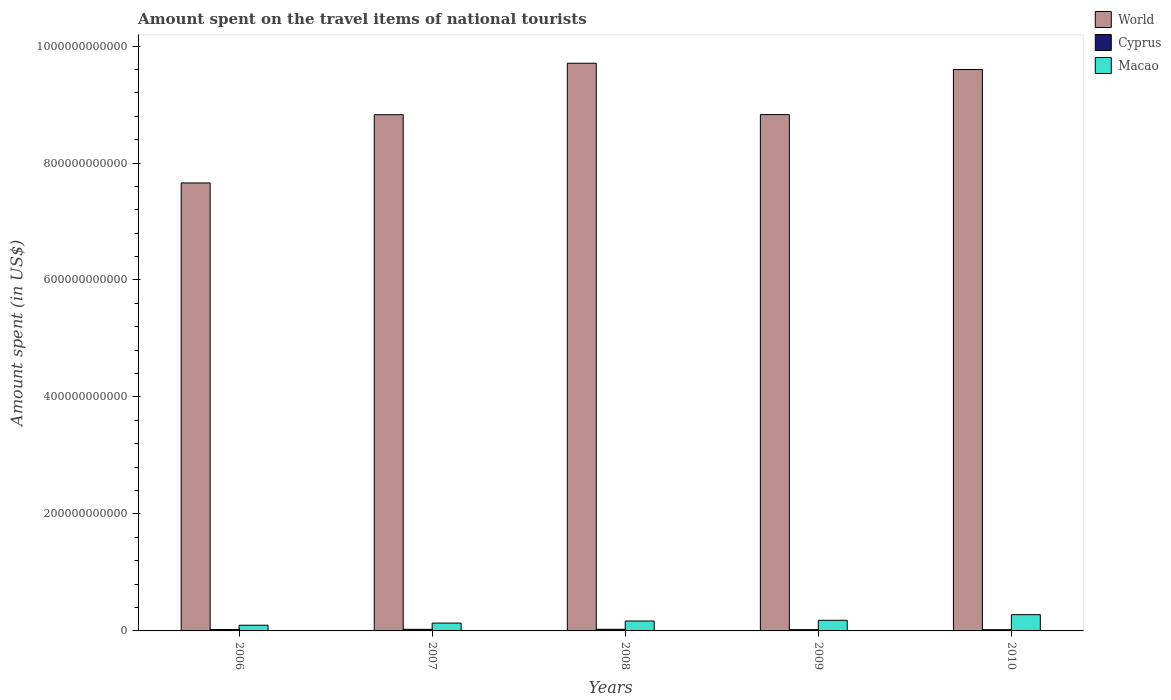How many groups of bars are there?
Make the answer very short. 5. Are the number of bars per tick equal to the number of legend labels?
Give a very brief answer. Yes. Are the number of bars on each tick of the X-axis equal?
Offer a terse response. Yes. How many bars are there on the 3rd tick from the left?
Provide a succinct answer. 3. How many bars are there on the 2nd tick from the right?
Make the answer very short. 3. What is the amount spent on the travel items of national tourists in Cyprus in 2006?
Ensure brevity in your answer.  2.38e+09. Across all years, what is the maximum amount spent on the travel items of national tourists in World?
Ensure brevity in your answer.  9.71e+11. Across all years, what is the minimum amount spent on the travel items of national tourists in Cyprus?
Give a very brief answer. 2.11e+09. What is the total amount spent on the travel items of national tourists in Macao in the graph?
Offer a very short reply. 8.60e+1. What is the difference between the amount spent on the travel items of national tourists in Cyprus in 2007 and that in 2010?
Offer a very short reply. 5.78e+08. What is the difference between the amount spent on the travel items of national tourists in Cyprus in 2008 and the amount spent on the travel items of national tourists in World in 2010?
Provide a short and direct response. -9.57e+11. What is the average amount spent on the travel items of national tourists in World per year?
Provide a succinct answer. 8.92e+11. In the year 2006, what is the difference between the amount spent on the travel items of national tourists in World and amount spent on the travel items of national tourists in Macao?
Make the answer very short. 7.56e+11. In how many years, is the amount spent on the travel items of national tourists in World greater than 360000000000 US$?
Offer a very short reply. 5. What is the ratio of the amount spent on the travel items of national tourists in World in 2006 to that in 2007?
Provide a short and direct response. 0.87. What is the difference between the highest and the second highest amount spent on the travel items of national tourists in World?
Provide a short and direct response. 1.07e+1. What is the difference between the highest and the lowest amount spent on the travel items of national tourists in World?
Offer a very short reply. 2.05e+11. Is the sum of the amount spent on the travel items of national tourists in World in 2007 and 2009 greater than the maximum amount spent on the travel items of national tourists in Macao across all years?
Your answer should be very brief. Yes. What does the 1st bar from the right in 2009 represents?
Offer a terse response. Macao. What is the difference between two consecutive major ticks on the Y-axis?
Offer a very short reply. 2.00e+11. Does the graph contain grids?
Keep it short and to the point. No. Where does the legend appear in the graph?
Your answer should be compact. Top right. How are the legend labels stacked?
Your response must be concise. Vertical. What is the title of the graph?
Your answer should be very brief. Amount spent on the travel items of national tourists. What is the label or title of the Y-axis?
Make the answer very short. Amount spent (in US$). What is the Amount spent (in US$) of World in 2006?
Ensure brevity in your answer.  7.66e+11. What is the Amount spent (in US$) of Cyprus in 2006?
Your response must be concise. 2.38e+09. What is the Amount spent (in US$) in Macao in 2006?
Keep it short and to the point. 9.75e+09. What is the Amount spent (in US$) of World in 2007?
Give a very brief answer. 8.83e+11. What is the Amount spent (in US$) in Cyprus in 2007?
Provide a succinct answer. 2.69e+09. What is the Amount spent (in US$) of Macao in 2007?
Ensure brevity in your answer.  1.34e+1. What is the Amount spent (in US$) of World in 2008?
Ensure brevity in your answer.  9.71e+11. What is the Amount spent (in US$) in Cyprus in 2008?
Provide a succinct answer. 2.78e+09. What is the Amount spent (in US$) of Macao in 2008?
Give a very brief answer. 1.69e+1. What is the Amount spent (in US$) of World in 2009?
Your answer should be compact. 8.83e+11. What is the Amount spent (in US$) of Cyprus in 2009?
Give a very brief answer. 2.20e+09. What is the Amount spent (in US$) of Macao in 2009?
Offer a terse response. 1.81e+1. What is the Amount spent (in US$) of World in 2010?
Your answer should be compact. 9.60e+11. What is the Amount spent (in US$) of Cyprus in 2010?
Provide a succinct answer. 2.11e+09. What is the Amount spent (in US$) in Macao in 2010?
Ensure brevity in your answer.  2.78e+1. Across all years, what is the maximum Amount spent (in US$) of World?
Keep it short and to the point. 9.71e+11. Across all years, what is the maximum Amount spent (in US$) in Cyprus?
Provide a short and direct response. 2.78e+09. Across all years, what is the maximum Amount spent (in US$) of Macao?
Your response must be concise. 2.78e+1. Across all years, what is the minimum Amount spent (in US$) in World?
Your response must be concise. 7.66e+11. Across all years, what is the minimum Amount spent (in US$) of Cyprus?
Offer a very short reply. 2.11e+09. Across all years, what is the minimum Amount spent (in US$) of Macao?
Offer a very short reply. 9.75e+09. What is the total Amount spent (in US$) of World in the graph?
Ensure brevity in your answer.  4.46e+12. What is the total Amount spent (in US$) of Cyprus in the graph?
Your response must be concise. 1.21e+1. What is the total Amount spent (in US$) of Macao in the graph?
Provide a short and direct response. 8.60e+1. What is the difference between the Amount spent (in US$) of World in 2006 and that in 2007?
Provide a short and direct response. -1.17e+11. What is the difference between the Amount spent (in US$) in Cyprus in 2006 and that in 2007?
Ensure brevity in your answer.  -3.05e+08. What is the difference between the Amount spent (in US$) of Macao in 2006 and that in 2007?
Offer a terse response. -3.66e+09. What is the difference between the Amount spent (in US$) of World in 2006 and that in 2008?
Your answer should be compact. -2.05e+11. What is the difference between the Amount spent (in US$) of Cyprus in 2006 and that in 2008?
Offer a terse response. -3.98e+08. What is the difference between the Amount spent (in US$) of Macao in 2006 and that in 2008?
Your answer should be compact. -7.20e+09. What is the difference between the Amount spent (in US$) in World in 2006 and that in 2009?
Ensure brevity in your answer.  -1.17e+11. What is the difference between the Amount spent (in US$) of Cyprus in 2006 and that in 2009?
Ensure brevity in your answer.  1.86e+08. What is the difference between the Amount spent (in US$) of Macao in 2006 and that in 2009?
Provide a succinct answer. -8.39e+09. What is the difference between the Amount spent (in US$) of World in 2006 and that in 2010?
Your response must be concise. -1.94e+11. What is the difference between the Amount spent (in US$) in Cyprus in 2006 and that in 2010?
Provide a short and direct response. 2.73e+08. What is the difference between the Amount spent (in US$) of Macao in 2006 and that in 2010?
Ensure brevity in your answer.  -1.81e+1. What is the difference between the Amount spent (in US$) in World in 2007 and that in 2008?
Your response must be concise. -8.79e+1. What is the difference between the Amount spent (in US$) of Cyprus in 2007 and that in 2008?
Ensure brevity in your answer.  -9.30e+07. What is the difference between the Amount spent (in US$) of Macao in 2007 and that in 2008?
Ensure brevity in your answer.  -3.54e+09. What is the difference between the Amount spent (in US$) of World in 2007 and that in 2009?
Ensure brevity in your answer.  -1.73e+08. What is the difference between the Amount spent (in US$) of Cyprus in 2007 and that in 2009?
Offer a very short reply. 4.91e+08. What is the difference between the Amount spent (in US$) of Macao in 2007 and that in 2009?
Offer a very short reply. -4.74e+09. What is the difference between the Amount spent (in US$) in World in 2007 and that in 2010?
Offer a very short reply. -7.72e+1. What is the difference between the Amount spent (in US$) in Cyprus in 2007 and that in 2010?
Make the answer very short. 5.78e+08. What is the difference between the Amount spent (in US$) of Macao in 2007 and that in 2010?
Keep it short and to the point. -1.44e+1. What is the difference between the Amount spent (in US$) of World in 2008 and that in 2009?
Ensure brevity in your answer.  8.78e+1. What is the difference between the Amount spent (in US$) in Cyprus in 2008 and that in 2009?
Provide a succinct answer. 5.84e+08. What is the difference between the Amount spent (in US$) in Macao in 2008 and that in 2009?
Make the answer very short. -1.19e+09. What is the difference between the Amount spent (in US$) in World in 2008 and that in 2010?
Ensure brevity in your answer.  1.07e+1. What is the difference between the Amount spent (in US$) of Cyprus in 2008 and that in 2010?
Your answer should be compact. 6.71e+08. What is the difference between the Amount spent (in US$) of Macao in 2008 and that in 2010?
Provide a succinct answer. -1.09e+1. What is the difference between the Amount spent (in US$) of World in 2009 and that in 2010?
Make the answer very short. -7.70e+1. What is the difference between the Amount spent (in US$) of Cyprus in 2009 and that in 2010?
Keep it short and to the point. 8.70e+07. What is the difference between the Amount spent (in US$) of Macao in 2009 and that in 2010?
Your response must be concise. -9.66e+09. What is the difference between the Amount spent (in US$) in World in 2006 and the Amount spent (in US$) in Cyprus in 2007?
Your answer should be very brief. 7.63e+11. What is the difference between the Amount spent (in US$) of World in 2006 and the Amount spent (in US$) of Macao in 2007?
Ensure brevity in your answer.  7.53e+11. What is the difference between the Amount spent (in US$) of Cyprus in 2006 and the Amount spent (in US$) of Macao in 2007?
Give a very brief answer. -1.10e+1. What is the difference between the Amount spent (in US$) in World in 2006 and the Amount spent (in US$) in Cyprus in 2008?
Ensure brevity in your answer.  7.63e+11. What is the difference between the Amount spent (in US$) of World in 2006 and the Amount spent (in US$) of Macao in 2008?
Offer a very short reply. 7.49e+11. What is the difference between the Amount spent (in US$) in Cyprus in 2006 and the Amount spent (in US$) in Macao in 2008?
Your answer should be very brief. -1.46e+1. What is the difference between the Amount spent (in US$) in World in 2006 and the Amount spent (in US$) in Cyprus in 2009?
Offer a terse response. 7.64e+11. What is the difference between the Amount spent (in US$) of World in 2006 and the Amount spent (in US$) of Macao in 2009?
Your answer should be very brief. 7.48e+11. What is the difference between the Amount spent (in US$) in Cyprus in 2006 and the Amount spent (in US$) in Macao in 2009?
Provide a short and direct response. -1.58e+1. What is the difference between the Amount spent (in US$) in World in 2006 and the Amount spent (in US$) in Cyprus in 2010?
Your response must be concise. 7.64e+11. What is the difference between the Amount spent (in US$) in World in 2006 and the Amount spent (in US$) in Macao in 2010?
Make the answer very short. 7.38e+11. What is the difference between the Amount spent (in US$) in Cyprus in 2006 and the Amount spent (in US$) in Macao in 2010?
Your answer should be very brief. -2.54e+1. What is the difference between the Amount spent (in US$) in World in 2007 and the Amount spent (in US$) in Cyprus in 2008?
Keep it short and to the point. 8.80e+11. What is the difference between the Amount spent (in US$) in World in 2007 and the Amount spent (in US$) in Macao in 2008?
Provide a short and direct response. 8.66e+11. What is the difference between the Amount spent (in US$) of Cyprus in 2007 and the Amount spent (in US$) of Macao in 2008?
Keep it short and to the point. -1.43e+1. What is the difference between the Amount spent (in US$) in World in 2007 and the Amount spent (in US$) in Cyprus in 2009?
Your answer should be very brief. 8.80e+11. What is the difference between the Amount spent (in US$) in World in 2007 and the Amount spent (in US$) in Macao in 2009?
Your answer should be compact. 8.64e+11. What is the difference between the Amount spent (in US$) of Cyprus in 2007 and the Amount spent (in US$) of Macao in 2009?
Your answer should be compact. -1.55e+1. What is the difference between the Amount spent (in US$) of World in 2007 and the Amount spent (in US$) of Cyprus in 2010?
Offer a very short reply. 8.81e+11. What is the difference between the Amount spent (in US$) in World in 2007 and the Amount spent (in US$) in Macao in 2010?
Ensure brevity in your answer.  8.55e+11. What is the difference between the Amount spent (in US$) in Cyprus in 2007 and the Amount spent (in US$) in Macao in 2010?
Your answer should be compact. -2.51e+1. What is the difference between the Amount spent (in US$) in World in 2008 and the Amount spent (in US$) in Cyprus in 2009?
Make the answer very short. 9.68e+11. What is the difference between the Amount spent (in US$) in World in 2008 and the Amount spent (in US$) in Macao in 2009?
Give a very brief answer. 9.52e+11. What is the difference between the Amount spent (in US$) of Cyprus in 2008 and the Amount spent (in US$) of Macao in 2009?
Provide a short and direct response. -1.54e+1. What is the difference between the Amount spent (in US$) of World in 2008 and the Amount spent (in US$) of Cyprus in 2010?
Give a very brief answer. 9.68e+11. What is the difference between the Amount spent (in US$) of World in 2008 and the Amount spent (in US$) of Macao in 2010?
Your response must be concise. 9.43e+11. What is the difference between the Amount spent (in US$) of Cyprus in 2008 and the Amount spent (in US$) of Macao in 2010?
Offer a very short reply. -2.50e+1. What is the difference between the Amount spent (in US$) of World in 2009 and the Amount spent (in US$) of Cyprus in 2010?
Offer a terse response. 8.81e+11. What is the difference between the Amount spent (in US$) of World in 2009 and the Amount spent (in US$) of Macao in 2010?
Provide a short and direct response. 8.55e+11. What is the difference between the Amount spent (in US$) of Cyprus in 2009 and the Amount spent (in US$) of Macao in 2010?
Make the answer very short. -2.56e+1. What is the average Amount spent (in US$) in World per year?
Offer a terse response. 8.92e+11. What is the average Amount spent (in US$) of Cyprus per year?
Ensure brevity in your answer.  2.43e+09. What is the average Amount spent (in US$) in Macao per year?
Provide a short and direct response. 1.72e+1. In the year 2006, what is the difference between the Amount spent (in US$) of World and Amount spent (in US$) of Cyprus?
Offer a terse response. 7.64e+11. In the year 2006, what is the difference between the Amount spent (in US$) of World and Amount spent (in US$) of Macao?
Ensure brevity in your answer.  7.56e+11. In the year 2006, what is the difference between the Amount spent (in US$) in Cyprus and Amount spent (in US$) in Macao?
Keep it short and to the point. -7.37e+09. In the year 2007, what is the difference between the Amount spent (in US$) of World and Amount spent (in US$) of Cyprus?
Your answer should be compact. 8.80e+11. In the year 2007, what is the difference between the Amount spent (in US$) in World and Amount spent (in US$) in Macao?
Your answer should be very brief. 8.69e+11. In the year 2007, what is the difference between the Amount spent (in US$) in Cyprus and Amount spent (in US$) in Macao?
Make the answer very short. -1.07e+1. In the year 2008, what is the difference between the Amount spent (in US$) of World and Amount spent (in US$) of Cyprus?
Keep it short and to the point. 9.68e+11. In the year 2008, what is the difference between the Amount spent (in US$) of World and Amount spent (in US$) of Macao?
Offer a very short reply. 9.54e+11. In the year 2008, what is the difference between the Amount spent (in US$) in Cyprus and Amount spent (in US$) in Macao?
Offer a very short reply. -1.42e+1. In the year 2009, what is the difference between the Amount spent (in US$) of World and Amount spent (in US$) of Cyprus?
Your answer should be compact. 8.81e+11. In the year 2009, what is the difference between the Amount spent (in US$) of World and Amount spent (in US$) of Macao?
Ensure brevity in your answer.  8.65e+11. In the year 2009, what is the difference between the Amount spent (in US$) in Cyprus and Amount spent (in US$) in Macao?
Provide a succinct answer. -1.59e+1. In the year 2010, what is the difference between the Amount spent (in US$) in World and Amount spent (in US$) in Cyprus?
Your answer should be compact. 9.58e+11. In the year 2010, what is the difference between the Amount spent (in US$) of World and Amount spent (in US$) of Macao?
Provide a short and direct response. 9.32e+11. In the year 2010, what is the difference between the Amount spent (in US$) of Cyprus and Amount spent (in US$) of Macao?
Give a very brief answer. -2.57e+1. What is the ratio of the Amount spent (in US$) in World in 2006 to that in 2007?
Ensure brevity in your answer.  0.87. What is the ratio of the Amount spent (in US$) of Cyprus in 2006 to that in 2007?
Offer a terse response. 0.89. What is the ratio of the Amount spent (in US$) of Macao in 2006 to that in 2007?
Provide a short and direct response. 0.73. What is the ratio of the Amount spent (in US$) of World in 2006 to that in 2008?
Your answer should be compact. 0.79. What is the ratio of the Amount spent (in US$) of Cyprus in 2006 to that in 2008?
Your answer should be compact. 0.86. What is the ratio of the Amount spent (in US$) of Macao in 2006 to that in 2008?
Provide a short and direct response. 0.58. What is the ratio of the Amount spent (in US$) in World in 2006 to that in 2009?
Your response must be concise. 0.87. What is the ratio of the Amount spent (in US$) in Cyprus in 2006 to that in 2009?
Keep it short and to the point. 1.08. What is the ratio of the Amount spent (in US$) of Macao in 2006 to that in 2009?
Your response must be concise. 0.54. What is the ratio of the Amount spent (in US$) of World in 2006 to that in 2010?
Your answer should be very brief. 0.8. What is the ratio of the Amount spent (in US$) of Cyprus in 2006 to that in 2010?
Offer a very short reply. 1.13. What is the ratio of the Amount spent (in US$) of Macao in 2006 to that in 2010?
Offer a terse response. 0.35. What is the ratio of the Amount spent (in US$) of World in 2007 to that in 2008?
Your answer should be compact. 0.91. What is the ratio of the Amount spent (in US$) in Cyprus in 2007 to that in 2008?
Offer a very short reply. 0.97. What is the ratio of the Amount spent (in US$) in Macao in 2007 to that in 2008?
Your response must be concise. 0.79. What is the ratio of the Amount spent (in US$) in Cyprus in 2007 to that in 2009?
Keep it short and to the point. 1.22. What is the ratio of the Amount spent (in US$) in Macao in 2007 to that in 2009?
Your answer should be compact. 0.74. What is the ratio of the Amount spent (in US$) of World in 2007 to that in 2010?
Provide a succinct answer. 0.92. What is the ratio of the Amount spent (in US$) of Cyprus in 2007 to that in 2010?
Your response must be concise. 1.27. What is the ratio of the Amount spent (in US$) in Macao in 2007 to that in 2010?
Keep it short and to the point. 0.48. What is the ratio of the Amount spent (in US$) in World in 2008 to that in 2009?
Offer a very short reply. 1.1. What is the ratio of the Amount spent (in US$) of Cyprus in 2008 to that in 2009?
Your answer should be very brief. 1.27. What is the ratio of the Amount spent (in US$) of Macao in 2008 to that in 2009?
Offer a terse response. 0.93. What is the ratio of the Amount spent (in US$) of World in 2008 to that in 2010?
Provide a short and direct response. 1.01. What is the ratio of the Amount spent (in US$) of Cyprus in 2008 to that in 2010?
Give a very brief answer. 1.32. What is the ratio of the Amount spent (in US$) of Macao in 2008 to that in 2010?
Provide a short and direct response. 0.61. What is the ratio of the Amount spent (in US$) of World in 2009 to that in 2010?
Make the answer very short. 0.92. What is the ratio of the Amount spent (in US$) of Cyprus in 2009 to that in 2010?
Your response must be concise. 1.04. What is the ratio of the Amount spent (in US$) in Macao in 2009 to that in 2010?
Provide a succinct answer. 0.65. What is the difference between the highest and the second highest Amount spent (in US$) in World?
Provide a succinct answer. 1.07e+1. What is the difference between the highest and the second highest Amount spent (in US$) in Cyprus?
Offer a very short reply. 9.30e+07. What is the difference between the highest and the second highest Amount spent (in US$) in Macao?
Provide a succinct answer. 9.66e+09. What is the difference between the highest and the lowest Amount spent (in US$) of World?
Your response must be concise. 2.05e+11. What is the difference between the highest and the lowest Amount spent (in US$) of Cyprus?
Keep it short and to the point. 6.71e+08. What is the difference between the highest and the lowest Amount spent (in US$) of Macao?
Give a very brief answer. 1.81e+1. 